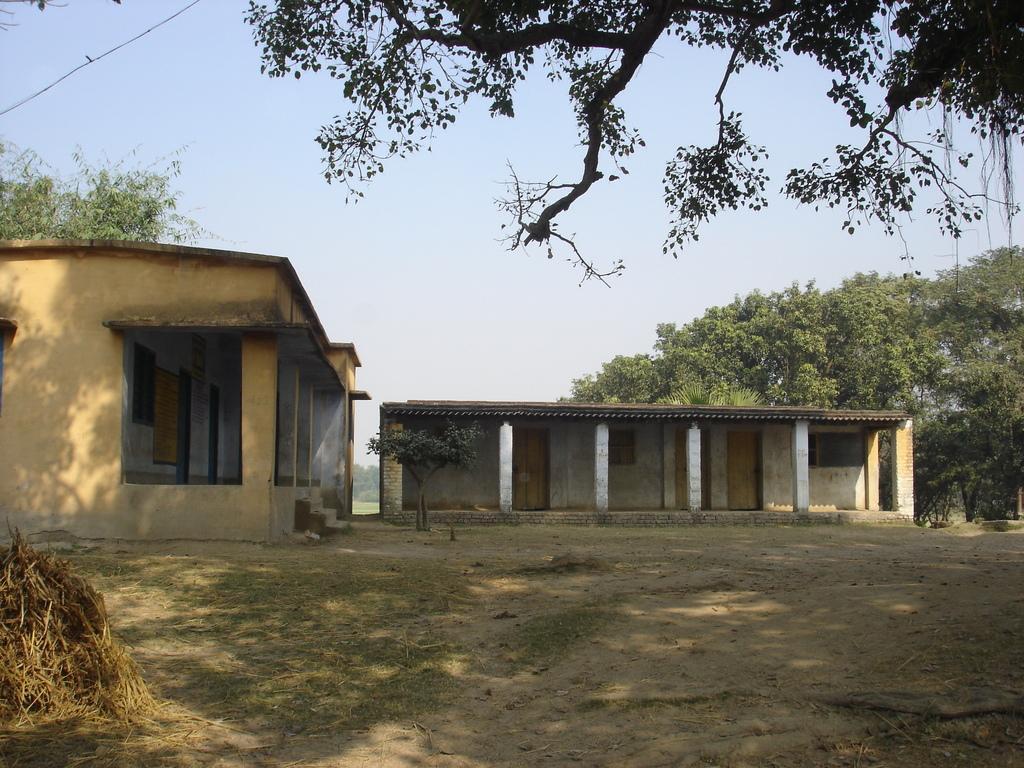Can you describe this image briefly? In this picture we can see the sheds, pillars, trees. At the bottom of the image we can see the grass and ground. In the bottom left corner we can see the heap of dry grass. At the top of the image we can see the sky. 